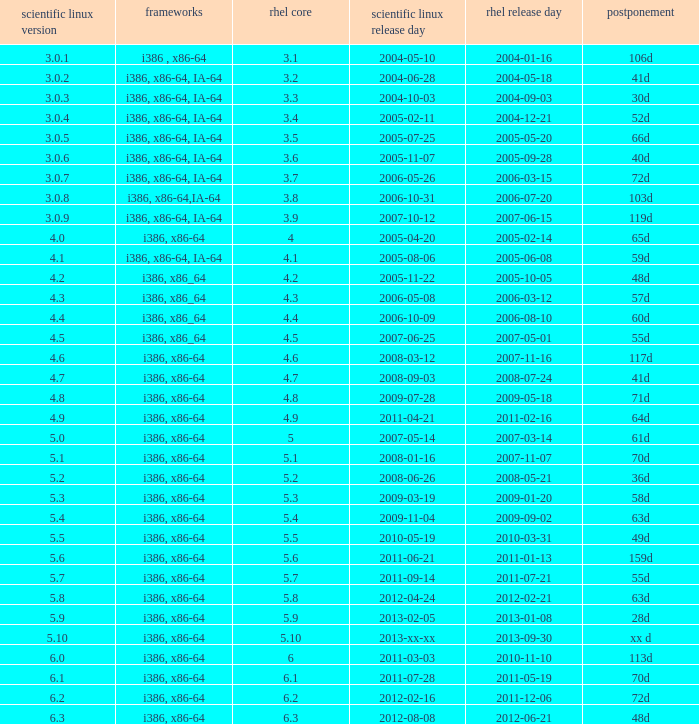Can you give me this table as a dict? {'header': ['scientific linux version', 'frameworks', 'rhel core', 'scientific linux release day', 'rhel release day', 'postponement'], 'rows': [['3.0.1', 'i386 , x86-64', '3.1', '2004-05-10', '2004-01-16', '106d'], ['3.0.2', 'i386, x86-64, IA-64', '3.2', '2004-06-28', '2004-05-18', '41d'], ['3.0.3', 'i386, x86-64, IA-64', '3.3', '2004-10-03', '2004-09-03', '30d'], ['3.0.4', 'i386, x86-64, IA-64', '3.4', '2005-02-11', '2004-12-21', '52d'], ['3.0.5', 'i386, x86-64, IA-64', '3.5', '2005-07-25', '2005-05-20', '66d'], ['3.0.6', 'i386, x86-64, IA-64', '3.6', '2005-11-07', '2005-09-28', '40d'], ['3.0.7', 'i386, x86-64, IA-64', '3.7', '2006-05-26', '2006-03-15', '72d'], ['3.0.8', 'i386, x86-64,IA-64', '3.8', '2006-10-31', '2006-07-20', '103d'], ['3.0.9', 'i386, x86-64, IA-64', '3.9', '2007-10-12', '2007-06-15', '119d'], ['4.0', 'i386, x86-64', '4', '2005-04-20', '2005-02-14', '65d'], ['4.1', 'i386, x86-64, IA-64', '4.1', '2005-08-06', '2005-06-08', '59d'], ['4.2', 'i386, x86_64', '4.2', '2005-11-22', '2005-10-05', '48d'], ['4.3', 'i386, x86_64', '4.3', '2006-05-08', '2006-03-12', '57d'], ['4.4', 'i386, x86_64', '4.4', '2006-10-09', '2006-08-10', '60d'], ['4.5', 'i386, x86_64', '4.5', '2007-06-25', '2007-05-01', '55d'], ['4.6', 'i386, x86-64', '4.6', '2008-03-12', '2007-11-16', '117d'], ['4.7', 'i386, x86-64', '4.7', '2008-09-03', '2008-07-24', '41d'], ['4.8', 'i386, x86-64', '4.8', '2009-07-28', '2009-05-18', '71d'], ['4.9', 'i386, x86-64', '4.9', '2011-04-21', '2011-02-16', '64d'], ['5.0', 'i386, x86-64', '5', '2007-05-14', '2007-03-14', '61d'], ['5.1', 'i386, x86-64', '5.1', '2008-01-16', '2007-11-07', '70d'], ['5.2', 'i386, x86-64', '5.2', '2008-06-26', '2008-05-21', '36d'], ['5.3', 'i386, x86-64', '5.3', '2009-03-19', '2009-01-20', '58d'], ['5.4', 'i386, x86-64', '5.4', '2009-11-04', '2009-09-02', '63d'], ['5.5', 'i386, x86-64', '5.5', '2010-05-19', '2010-03-31', '49d'], ['5.6', 'i386, x86-64', '5.6', '2011-06-21', '2011-01-13', '159d'], ['5.7', 'i386, x86-64', '5.7', '2011-09-14', '2011-07-21', '55d'], ['5.8', 'i386, x86-64', '5.8', '2012-04-24', '2012-02-21', '63d'], ['5.9', 'i386, x86-64', '5.9', '2013-02-05', '2013-01-08', '28d'], ['5.10', 'i386, x86-64', '5.10', '2013-xx-xx', '2013-09-30', 'xx d'], ['6.0', 'i386, x86-64', '6', '2011-03-03', '2010-11-10', '113d'], ['6.1', 'i386, x86-64', '6.1', '2011-07-28', '2011-05-19', '70d'], ['6.2', 'i386, x86-64', '6.2', '2012-02-16', '2011-12-06', '72d'], ['6.3', 'i386, x86-64', '6.3', '2012-08-08', '2012-06-21', '48d']]} When is the rhel release date when scientific linux release is 3.0.4 2004-12-21. 